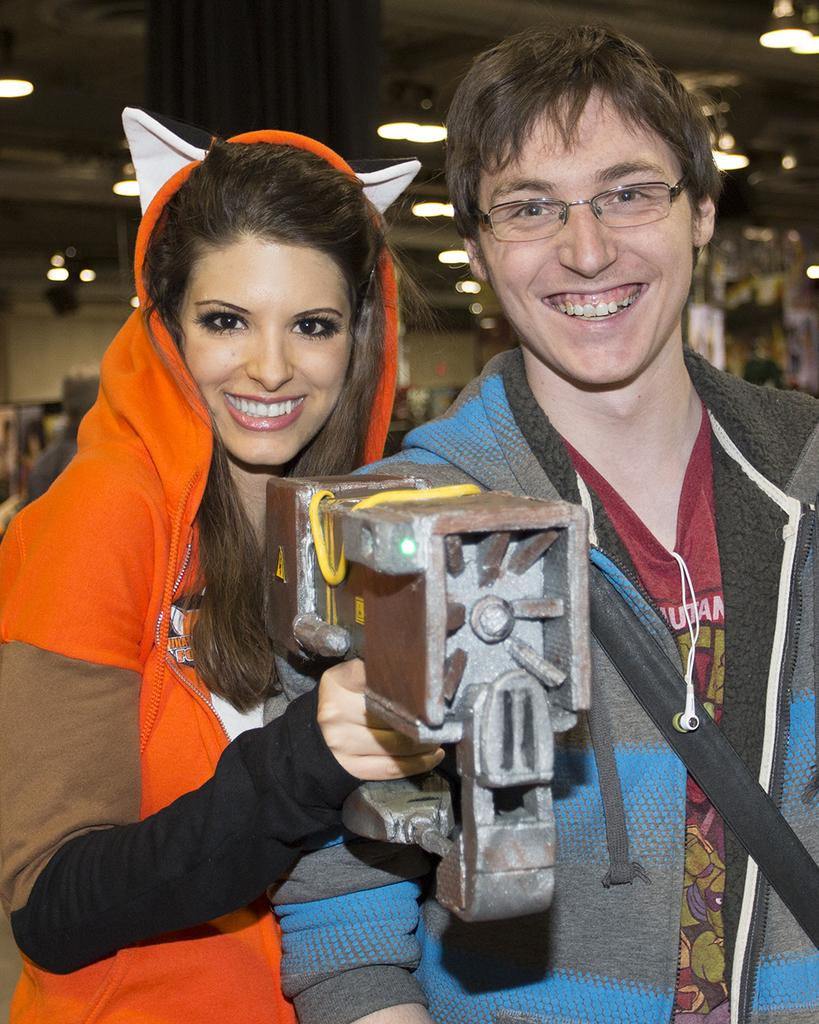What can be observed about the people in the image? There are persons wearing clothes in the image. Can you describe the position of the person on the left side of the image? There is a person on the left side of the image. What is the person on the left side doing? The person on the left side is holding an object with her hand. How would you describe the background of the image? The background of the image is blurred. What type of protest is happening in the image? There is no protest present in the image. Can you tell me what is inside the bottle that the person on the left side is holding? There is no bottle present in the image; the person on the left side is holding an unspecified object. 